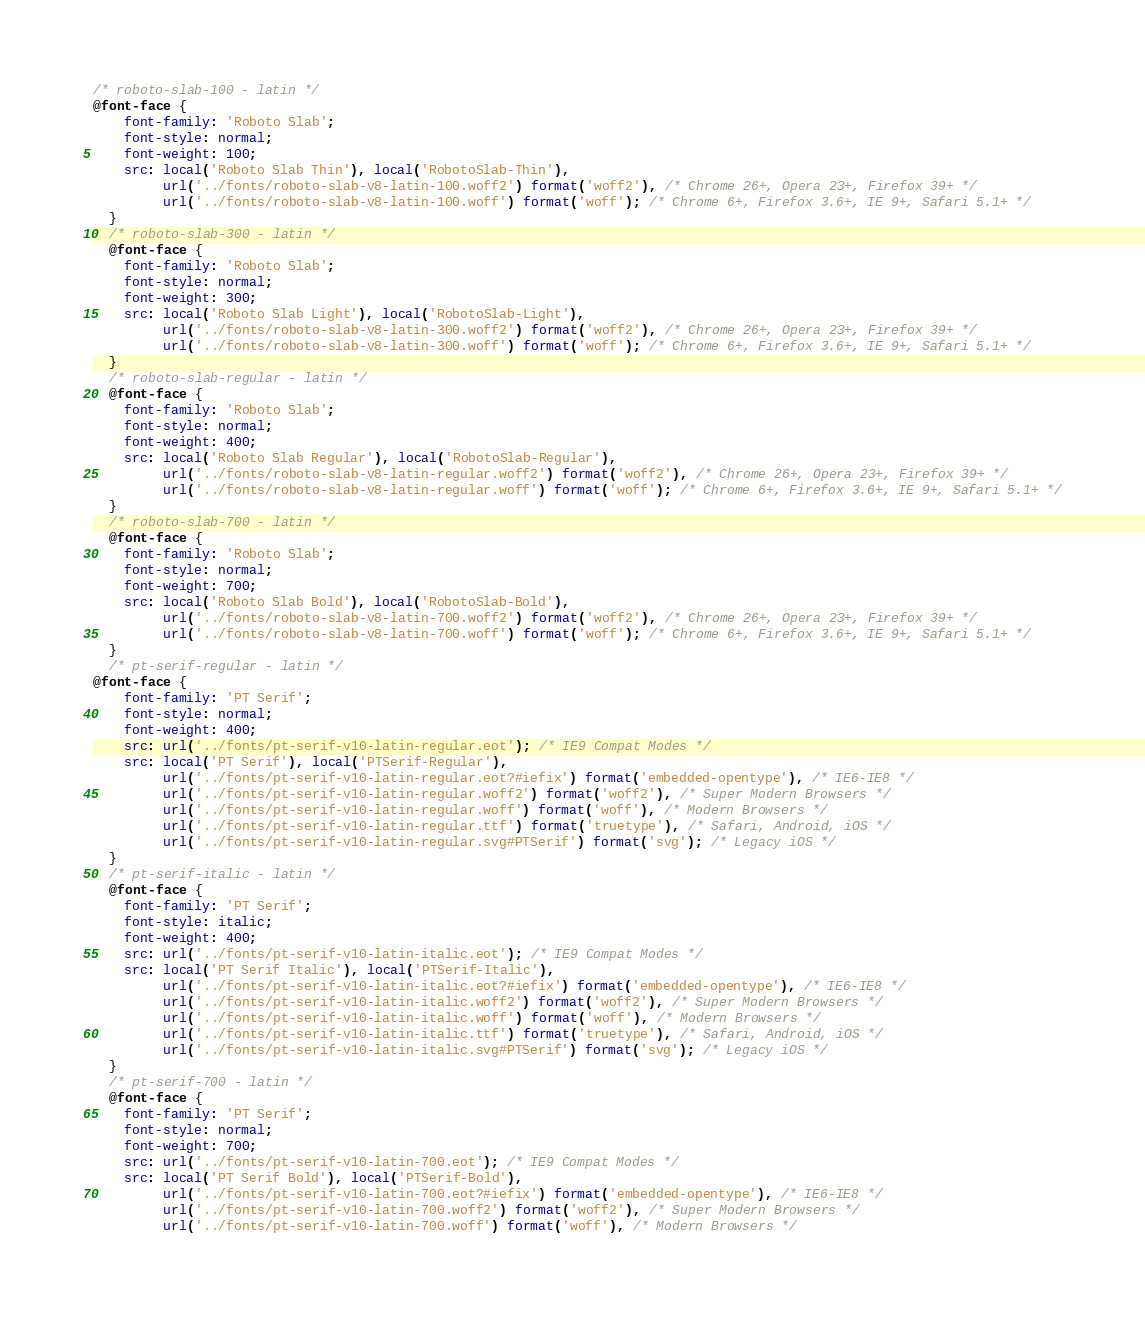<code> <loc_0><loc_0><loc_500><loc_500><_CSS_>/* roboto-slab-100 - latin */
@font-face {
    font-family: 'Roboto Slab';
    font-style: normal;
    font-weight: 100;
    src: local('Roboto Slab Thin'), local('RobotoSlab-Thin'),
         url('../fonts/roboto-slab-v8-latin-100.woff2') format('woff2'), /* Chrome 26+, Opera 23+, Firefox 39+ */
         url('../fonts/roboto-slab-v8-latin-100.woff') format('woff'); /* Chrome 6+, Firefox 3.6+, IE 9+, Safari 5.1+ */
  }
  /* roboto-slab-300 - latin */
  @font-face {
    font-family: 'Roboto Slab';
    font-style: normal;
    font-weight: 300;
    src: local('Roboto Slab Light'), local('RobotoSlab-Light'),
         url('../fonts/roboto-slab-v8-latin-300.woff2') format('woff2'), /* Chrome 26+, Opera 23+, Firefox 39+ */
         url('../fonts/roboto-slab-v8-latin-300.woff') format('woff'); /* Chrome 6+, Firefox 3.6+, IE 9+, Safari 5.1+ */
  }
  /* roboto-slab-regular - latin */
  @font-face {
    font-family: 'Roboto Slab';
    font-style: normal;
    font-weight: 400;
    src: local('Roboto Slab Regular'), local('RobotoSlab-Regular'),
         url('../fonts/roboto-slab-v8-latin-regular.woff2') format('woff2'), /* Chrome 26+, Opera 23+, Firefox 39+ */
         url('../fonts/roboto-slab-v8-latin-regular.woff') format('woff'); /* Chrome 6+, Firefox 3.6+, IE 9+, Safari 5.1+ */
  }
  /* roboto-slab-700 - latin */
  @font-face {
    font-family: 'Roboto Slab';
    font-style: normal;
    font-weight: 700;
    src: local('Roboto Slab Bold'), local('RobotoSlab-Bold'),
         url('../fonts/roboto-slab-v8-latin-700.woff2') format('woff2'), /* Chrome 26+, Opera 23+, Firefox 39+ */
         url('../fonts/roboto-slab-v8-latin-700.woff') format('woff'); /* Chrome 6+, Firefox 3.6+, IE 9+, Safari 5.1+ */
  }
  /* pt-serif-regular - latin */
@font-face {
    font-family: 'PT Serif';
    font-style: normal;
    font-weight: 400;
    src: url('../fonts/pt-serif-v10-latin-regular.eot'); /* IE9 Compat Modes */
    src: local('PT Serif'), local('PTSerif-Regular'),
         url('../fonts/pt-serif-v10-latin-regular.eot?#iefix') format('embedded-opentype'), /* IE6-IE8 */
         url('../fonts/pt-serif-v10-latin-regular.woff2') format('woff2'), /* Super Modern Browsers */
         url('../fonts/pt-serif-v10-latin-regular.woff') format('woff'), /* Modern Browsers */
         url('../fonts/pt-serif-v10-latin-regular.ttf') format('truetype'), /* Safari, Android, iOS */
         url('../fonts/pt-serif-v10-latin-regular.svg#PTSerif') format('svg'); /* Legacy iOS */
  }
  /* pt-serif-italic - latin */
  @font-face {
    font-family: 'PT Serif';
    font-style: italic;
    font-weight: 400;
    src: url('../fonts/pt-serif-v10-latin-italic.eot'); /* IE9 Compat Modes */
    src: local('PT Serif Italic'), local('PTSerif-Italic'),
         url('../fonts/pt-serif-v10-latin-italic.eot?#iefix') format('embedded-opentype'), /* IE6-IE8 */
         url('../fonts/pt-serif-v10-latin-italic.woff2') format('woff2'), /* Super Modern Browsers */
         url('../fonts/pt-serif-v10-latin-italic.woff') format('woff'), /* Modern Browsers */
         url('../fonts/pt-serif-v10-latin-italic.ttf') format('truetype'), /* Safari, Android, iOS */
         url('../fonts/pt-serif-v10-latin-italic.svg#PTSerif') format('svg'); /* Legacy iOS */
  }
  /* pt-serif-700 - latin */
  @font-face {
    font-family: 'PT Serif';
    font-style: normal;
    font-weight: 700;
    src: url('../fonts/pt-serif-v10-latin-700.eot'); /* IE9 Compat Modes */
    src: local('PT Serif Bold'), local('PTSerif-Bold'),
         url('../fonts/pt-serif-v10-latin-700.eot?#iefix') format('embedded-opentype'), /* IE6-IE8 */
         url('../fonts/pt-serif-v10-latin-700.woff2') format('woff2'), /* Super Modern Browsers */
         url('../fonts/pt-serif-v10-latin-700.woff') format('woff'), /* Modern Browsers */</code> 